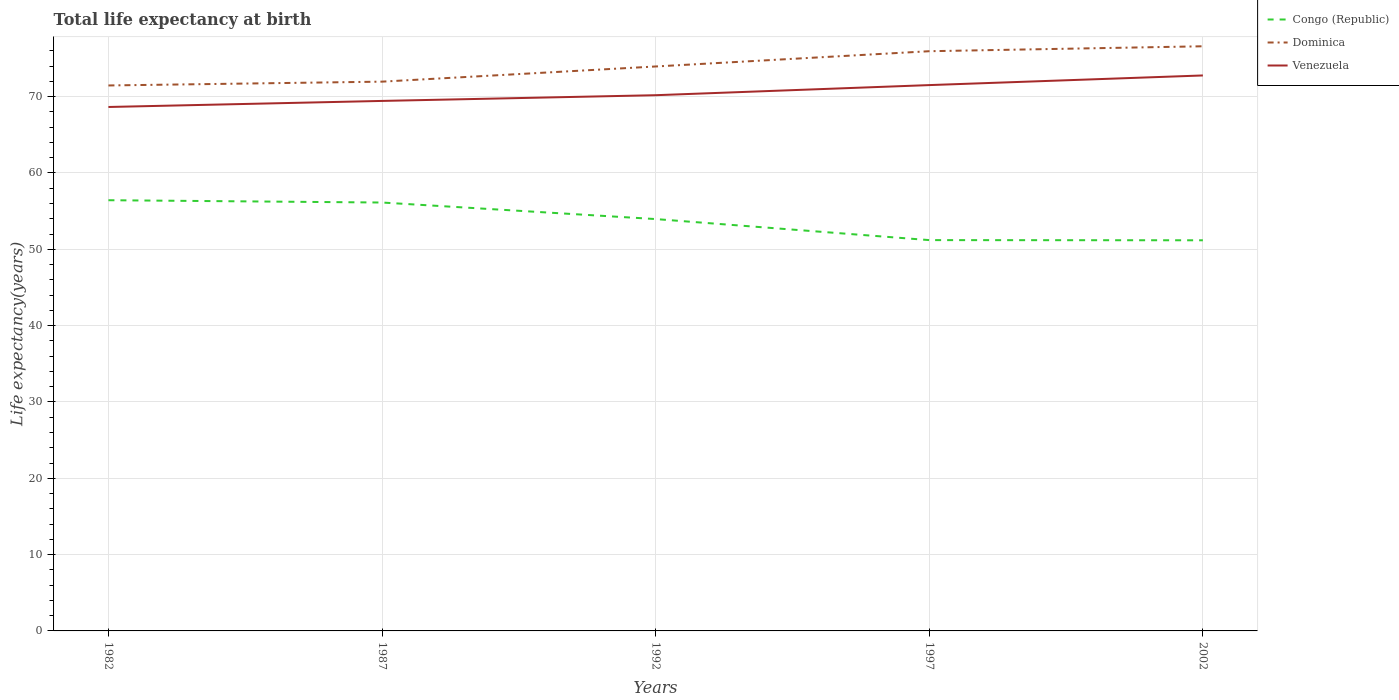How many different coloured lines are there?
Your response must be concise. 3. Does the line corresponding to Venezuela intersect with the line corresponding to Congo (Republic)?
Make the answer very short. No. Across all years, what is the maximum life expectancy at birth in in Congo (Republic)?
Offer a terse response. 51.18. What is the total life expectancy at birth in in Dominica in the graph?
Make the answer very short. -0.65. What is the difference between the highest and the second highest life expectancy at birth in in Venezuela?
Keep it short and to the point. 4.13. Are the values on the major ticks of Y-axis written in scientific E-notation?
Make the answer very short. No. Does the graph contain grids?
Keep it short and to the point. Yes. Where does the legend appear in the graph?
Your response must be concise. Top right. What is the title of the graph?
Offer a very short reply. Total life expectancy at birth. Does "St. Vincent and the Grenadines" appear as one of the legend labels in the graph?
Ensure brevity in your answer.  No. What is the label or title of the X-axis?
Your response must be concise. Years. What is the label or title of the Y-axis?
Your answer should be very brief. Life expectancy(years). What is the Life expectancy(years) in Congo (Republic) in 1982?
Make the answer very short. 56.43. What is the Life expectancy(years) in Dominica in 1982?
Give a very brief answer. 71.46. What is the Life expectancy(years) of Venezuela in 1982?
Ensure brevity in your answer.  68.64. What is the Life expectancy(years) of Congo (Republic) in 1987?
Keep it short and to the point. 56.13. What is the Life expectancy(years) of Dominica in 1987?
Make the answer very short. 71.96. What is the Life expectancy(years) of Venezuela in 1987?
Offer a terse response. 69.44. What is the Life expectancy(years) of Congo (Republic) in 1992?
Give a very brief answer. 53.96. What is the Life expectancy(years) of Dominica in 1992?
Offer a very short reply. 73.95. What is the Life expectancy(years) in Venezuela in 1992?
Offer a terse response. 70.19. What is the Life expectancy(years) of Congo (Republic) in 1997?
Your answer should be very brief. 51.2. What is the Life expectancy(years) of Dominica in 1997?
Offer a terse response. 75.95. What is the Life expectancy(years) of Venezuela in 1997?
Your response must be concise. 71.51. What is the Life expectancy(years) of Congo (Republic) in 2002?
Provide a short and direct response. 51.18. What is the Life expectancy(years) of Dominica in 2002?
Offer a very short reply. 76.6. What is the Life expectancy(years) of Venezuela in 2002?
Keep it short and to the point. 72.78. Across all years, what is the maximum Life expectancy(years) of Congo (Republic)?
Your answer should be compact. 56.43. Across all years, what is the maximum Life expectancy(years) in Dominica?
Provide a short and direct response. 76.6. Across all years, what is the maximum Life expectancy(years) of Venezuela?
Provide a short and direct response. 72.78. Across all years, what is the minimum Life expectancy(years) in Congo (Republic)?
Offer a terse response. 51.18. Across all years, what is the minimum Life expectancy(years) in Dominica?
Provide a short and direct response. 71.46. Across all years, what is the minimum Life expectancy(years) of Venezuela?
Offer a very short reply. 68.64. What is the total Life expectancy(years) in Congo (Republic) in the graph?
Ensure brevity in your answer.  268.9. What is the total Life expectancy(years) in Dominica in the graph?
Offer a very short reply. 369.93. What is the total Life expectancy(years) in Venezuela in the graph?
Your answer should be compact. 352.56. What is the difference between the Life expectancy(years) of Congo (Republic) in 1982 and that in 1987?
Provide a succinct answer. 0.3. What is the difference between the Life expectancy(years) in Venezuela in 1982 and that in 1987?
Give a very brief answer. -0.79. What is the difference between the Life expectancy(years) of Congo (Republic) in 1982 and that in 1992?
Your answer should be compact. 2.47. What is the difference between the Life expectancy(years) in Dominica in 1982 and that in 1992?
Offer a very short reply. -2.49. What is the difference between the Life expectancy(years) of Venezuela in 1982 and that in 1992?
Offer a very short reply. -1.54. What is the difference between the Life expectancy(years) in Congo (Republic) in 1982 and that in 1997?
Give a very brief answer. 5.23. What is the difference between the Life expectancy(years) in Dominica in 1982 and that in 1997?
Ensure brevity in your answer.  -4.49. What is the difference between the Life expectancy(years) of Venezuela in 1982 and that in 1997?
Make the answer very short. -2.87. What is the difference between the Life expectancy(years) in Congo (Republic) in 1982 and that in 2002?
Provide a succinct answer. 5.25. What is the difference between the Life expectancy(years) in Dominica in 1982 and that in 2002?
Ensure brevity in your answer.  -5.13. What is the difference between the Life expectancy(years) of Venezuela in 1982 and that in 2002?
Ensure brevity in your answer.  -4.13. What is the difference between the Life expectancy(years) of Congo (Republic) in 1987 and that in 1992?
Your answer should be very brief. 2.17. What is the difference between the Life expectancy(years) of Dominica in 1987 and that in 1992?
Your response must be concise. -1.99. What is the difference between the Life expectancy(years) of Venezuela in 1987 and that in 1992?
Your answer should be compact. -0.75. What is the difference between the Life expectancy(years) of Congo (Republic) in 1987 and that in 1997?
Your response must be concise. 4.92. What is the difference between the Life expectancy(years) of Dominica in 1987 and that in 1997?
Give a very brief answer. -3.99. What is the difference between the Life expectancy(years) of Venezuela in 1987 and that in 1997?
Offer a terse response. -2.07. What is the difference between the Life expectancy(years) in Congo (Republic) in 1987 and that in 2002?
Give a very brief answer. 4.95. What is the difference between the Life expectancy(years) in Dominica in 1987 and that in 2002?
Provide a succinct answer. -4.63. What is the difference between the Life expectancy(years) of Venezuela in 1987 and that in 2002?
Give a very brief answer. -3.34. What is the difference between the Life expectancy(years) in Congo (Republic) in 1992 and that in 1997?
Your answer should be compact. 2.76. What is the difference between the Life expectancy(years) of Venezuela in 1992 and that in 1997?
Provide a short and direct response. -1.32. What is the difference between the Life expectancy(years) in Congo (Republic) in 1992 and that in 2002?
Your answer should be compact. 2.78. What is the difference between the Life expectancy(years) in Dominica in 1992 and that in 2002?
Give a very brief answer. -2.65. What is the difference between the Life expectancy(years) of Venezuela in 1992 and that in 2002?
Give a very brief answer. -2.59. What is the difference between the Life expectancy(years) in Congo (Republic) in 1997 and that in 2002?
Your response must be concise. 0.02. What is the difference between the Life expectancy(years) in Dominica in 1997 and that in 2002?
Keep it short and to the point. -0.65. What is the difference between the Life expectancy(years) in Venezuela in 1997 and that in 2002?
Give a very brief answer. -1.26. What is the difference between the Life expectancy(years) of Congo (Republic) in 1982 and the Life expectancy(years) of Dominica in 1987?
Give a very brief answer. -15.53. What is the difference between the Life expectancy(years) in Congo (Republic) in 1982 and the Life expectancy(years) in Venezuela in 1987?
Give a very brief answer. -13.01. What is the difference between the Life expectancy(years) in Dominica in 1982 and the Life expectancy(years) in Venezuela in 1987?
Your answer should be compact. 2.03. What is the difference between the Life expectancy(years) in Congo (Republic) in 1982 and the Life expectancy(years) in Dominica in 1992?
Give a very brief answer. -17.52. What is the difference between the Life expectancy(years) in Congo (Republic) in 1982 and the Life expectancy(years) in Venezuela in 1992?
Give a very brief answer. -13.76. What is the difference between the Life expectancy(years) of Dominica in 1982 and the Life expectancy(years) of Venezuela in 1992?
Provide a succinct answer. 1.28. What is the difference between the Life expectancy(years) of Congo (Republic) in 1982 and the Life expectancy(years) of Dominica in 1997?
Keep it short and to the point. -19.52. What is the difference between the Life expectancy(years) in Congo (Republic) in 1982 and the Life expectancy(years) in Venezuela in 1997?
Your answer should be very brief. -15.08. What is the difference between the Life expectancy(years) of Dominica in 1982 and the Life expectancy(years) of Venezuela in 1997?
Make the answer very short. -0.05. What is the difference between the Life expectancy(years) of Congo (Republic) in 1982 and the Life expectancy(years) of Dominica in 2002?
Give a very brief answer. -20.17. What is the difference between the Life expectancy(years) of Congo (Republic) in 1982 and the Life expectancy(years) of Venezuela in 2002?
Your response must be concise. -16.35. What is the difference between the Life expectancy(years) in Dominica in 1982 and the Life expectancy(years) in Venezuela in 2002?
Provide a succinct answer. -1.31. What is the difference between the Life expectancy(years) of Congo (Republic) in 1987 and the Life expectancy(years) of Dominica in 1992?
Ensure brevity in your answer.  -17.82. What is the difference between the Life expectancy(years) of Congo (Republic) in 1987 and the Life expectancy(years) of Venezuela in 1992?
Provide a succinct answer. -14.06. What is the difference between the Life expectancy(years) in Dominica in 1987 and the Life expectancy(years) in Venezuela in 1992?
Ensure brevity in your answer.  1.78. What is the difference between the Life expectancy(years) of Congo (Republic) in 1987 and the Life expectancy(years) of Dominica in 1997?
Keep it short and to the point. -19.82. What is the difference between the Life expectancy(years) in Congo (Republic) in 1987 and the Life expectancy(years) in Venezuela in 1997?
Your answer should be very brief. -15.39. What is the difference between the Life expectancy(years) in Dominica in 1987 and the Life expectancy(years) in Venezuela in 1997?
Your response must be concise. 0.45. What is the difference between the Life expectancy(years) of Congo (Republic) in 1987 and the Life expectancy(years) of Dominica in 2002?
Give a very brief answer. -20.47. What is the difference between the Life expectancy(years) of Congo (Republic) in 1987 and the Life expectancy(years) of Venezuela in 2002?
Provide a succinct answer. -16.65. What is the difference between the Life expectancy(years) in Dominica in 1987 and the Life expectancy(years) in Venezuela in 2002?
Make the answer very short. -0.81. What is the difference between the Life expectancy(years) in Congo (Republic) in 1992 and the Life expectancy(years) in Dominica in 1997?
Make the answer very short. -21.99. What is the difference between the Life expectancy(years) of Congo (Republic) in 1992 and the Life expectancy(years) of Venezuela in 1997?
Ensure brevity in your answer.  -17.55. What is the difference between the Life expectancy(years) of Dominica in 1992 and the Life expectancy(years) of Venezuela in 1997?
Make the answer very short. 2.44. What is the difference between the Life expectancy(years) in Congo (Republic) in 1992 and the Life expectancy(years) in Dominica in 2002?
Ensure brevity in your answer.  -22.64. What is the difference between the Life expectancy(years) of Congo (Republic) in 1992 and the Life expectancy(years) of Venezuela in 2002?
Offer a very short reply. -18.82. What is the difference between the Life expectancy(years) in Dominica in 1992 and the Life expectancy(years) in Venezuela in 2002?
Ensure brevity in your answer.  1.18. What is the difference between the Life expectancy(years) in Congo (Republic) in 1997 and the Life expectancy(years) in Dominica in 2002?
Ensure brevity in your answer.  -25.4. What is the difference between the Life expectancy(years) in Congo (Republic) in 1997 and the Life expectancy(years) in Venezuela in 2002?
Offer a terse response. -21.57. What is the difference between the Life expectancy(years) in Dominica in 1997 and the Life expectancy(years) in Venezuela in 2002?
Ensure brevity in your answer.  3.18. What is the average Life expectancy(years) in Congo (Republic) per year?
Keep it short and to the point. 53.78. What is the average Life expectancy(years) of Dominica per year?
Offer a very short reply. 73.99. What is the average Life expectancy(years) of Venezuela per year?
Your response must be concise. 70.51. In the year 1982, what is the difference between the Life expectancy(years) of Congo (Republic) and Life expectancy(years) of Dominica?
Make the answer very short. -15.03. In the year 1982, what is the difference between the Life expectancy(years) of Congo (Republic) and Life expectancy(years) of Venezuela?
Provide a short and direct response. -12.22. In the year 1982, what is the difference between the Life expectancy(years) of Dominica and Life expectancy(years) of Venezuela?
Offer a very short reply. 2.82. In the year 1987, what is the difference between the Life expectancy(years) in Congo (Republic) and Life expectancy(years) in Dominica?
Ensure brevity in your answer.  -15.84. In the year 1987, what is the difference between the Life expectancy(years) in Congo (Republic) and Life expectancy(years) in Venezuela?
Provide a short and direct response. -13.31. In the year 1987, what is the difference between the Life expectancy(years) of Dominica and Life expectancy(years) of Venezuela?
Keep it short and to the point. 2.53. In the year 1992, what is the difference between the Life expectancy(years) in Congo (Republic) and Life expectancy(years) in Dominica?
Offer a very short reply. -19.99. In the year 1992, what is the difference between the Life expectancy(years) of Congo (Republic) and Life expectancy(years) of Venezuela?
Provide a short and direct response. -16.23. In the year 1992, what is the difference between the Life expectancy(years) of Dominica and Life expectancy(years) of Venezuela?
Offer a terse response. 3.76. In the year 1997, what is the difference between the Life expectancy(years) in Congo (Republic) and Life expectancy(years) in Dominica?
Your answer should be very brief. -24.75. In the year 1997, what is the difference between the Life expectancy(years) of Congo (Republic) and Life expectancy(years) of Venezuela?
Your answer should be compact. -20.31. In the year 1997, what is the difference between the Life expectancy(years) in Dominica and Life expectancy(years) in Venezuela?
Your answer should be very brief. 4.44. In the year 2002, what is the difference between the Life expectancy(years) of Congo (Republic) and Life expectancy(years) of Dominica?
Offer a terse response. -25.42. In the year 2002, what is the difference between the Life expectancy(years) of Congo (Republic) and Life expectancy(years) of Venezuela?
Keep it short and to the point. -21.6. In the year 2002, what is the difference between the Life expectancy(years) in Dominica and Life expectancy(years) in Venezuela?
Ensure brevity in your answer.  3.82. What is the ratio of the Life expectancy(years) in Congo (Republic) in 1982 to that in 1987?
Your response must be concise. 1.01. What is the ratio of the Life expectancy(years) in Dominica in 1982 to that in 1987?
Provide a short and direct response. 0.99. What is the ratio of the Life expectancy(years) of Congo (Republic) in 1982 to that in 1992?
Offer a terse response. 1.05. What is the ratio of the Life expectancy(years) of Dominica in 1982 to that in 1992?
Keep it short and to the point. 0.97. What is the ratio of the Life expectancy(years) of Venezuela in 1982 to that in 1992?
Your answer should be compact. 0.98. What is the ratio of the Life expectancy(years) of Congo (Republic) in 1982 to that in 1997?
Provide a short and direct response. 1.1. What is the ratio of the Life expectancy(years) in Dominica in 1982 to that in 1997?
Make the answer very short. 0.94. What is the ratio of the Life expectancy(years) of Venezuela in 1982 to that in 1997?
Your answer should be very brief. 0.96. What is the ratio of the Life expectancy(years) of Congo (Republic) in 1982 to that in 2002?
Provide a succinct answer. 1.1. What is the ratio of the Life expectancy(years) in Dominica in 1982 to that in 2002?
Offer a terse response. 0.93. What is the ratio of the Life expectancy(years) in Venezuela in 1982 to that in 2002?
Your answer should be very brief. 0.94. What is the ratio of the Life expectancy(years) in Congo (Republic) in 1987 to that in 1992?
Give a very brief answer. 1.04. What is the ratio of the Life expectancy(years) of Dominica in 1987 to that in 1992?
Your response must be concise. 0.97. What is the ratio of the Life expectancy(years) in Venezuela in 1987 to that in 1992?
Provide a succinct answer. 0.99. What is the ratio of the Life expectancy(years) of Congo (Republic) in 1987 to that in 1997?
Make the answer very short. 1.1. What is the ratio of the Life expectancy(years) of Dominica in 1987 to that in 1997?
Ensure brevity in your answer.  0.95. What is the ratio of the Life expectancy(years) of Congo (Republic) in 1987 to that in 2002?
Give a very brief answer. 1.1. What is the ratio of the Life expectancy(years) in Dominica in 1987 to that in 2002?
Your response must be concise. 0.94. What is the ratio of the Life expectancy(years) of Venezuela in 1987 to that in 2002?
Provide a short and direct response. 0.95. What is the ratio of the Life expectancy(years) of Congo (Republic) in 1992 to that in 1997?
Provide a short and direct response. 1.05. What is the ratio of the Life expectancy(years) in Dominica in 1992 to that in 1997?
Keep it short and to the point. 0.97. What is the ratio of the Life expectancy(years) of Venezuela in 1992 to that in 1997?
Your response must be concise. 0.98. What is the ratio of the Life expectancy(years) in Congo (Republic) in 1992 to that in 2002?
Make the answer very short. 1.05. What is the ratio of the Life expectancy(years) of Dominica in 1992 to that in 2002?
Give a very brief answer. 0.97. What is the ratio of the Life expectancy(years) in Venezuela in 1992 to that in 2002?
Keep it short and to the point. 0.96. What is the ratio of the Life expectancy(years) of Dominica in 1997 to that in 2002?
Offer a terse response. 0.99. What is the ratio of the Life expectancy(years) of Venezuela in 1997 to that in 2002?
Offer a terse response. 0.98. What is the difference between the highest and the second highest Life expectancy(years) of Congo (Republic)?
Offer a terse response. 0.3. What is the difference between the highest and the second highest Life expectancy(years) of Dominica?
Offer a terse response. 0.65. What is the difference between the highest and the second highest Life expectancy(years) of Venezuela?
Your answer should be compact. 1.26. What is the difference between the highest and the lowest Life expectancy(years) in Congo (Republic)?
Ensure brevity in your answer.  5.25. What is the difference between the highest and the lowest Life expectancy(years) of Dominica?
Offer a very short reply. 5.13. What is the difference between the highest and the lowest Life expectancy(years) in Venezuela?
Ensure brevity in your answer.  4.13. 